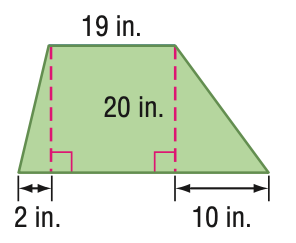Question: Find the area of the trapezoid.
Choices:
A. 125
B. 250
C. 500
D. 1000
Answer with the letter. Answer: C 